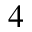Convert formula to latex. <formula><loc_0><loc_0><loc_500><loc_500>_ { 4 }</formula> 